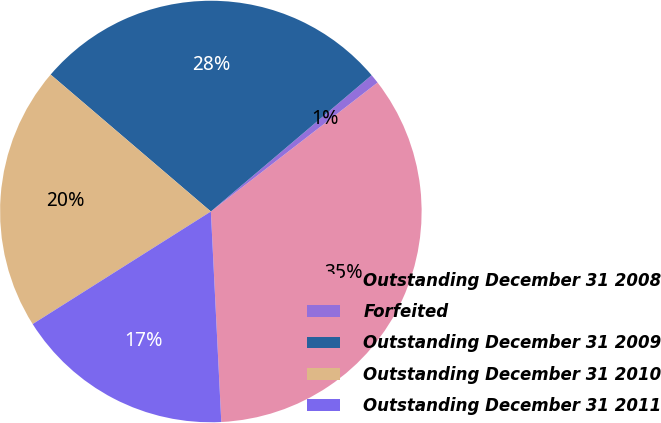Convert chart to OTSL. <chart><loc_0><loc_0><loc_500><loc_500><pie_chart><fcel>Outstanding December 31 2008<fcel>Forfeited<fcel>Outstanding December 31 2009<fcel>Outstanding December 31 2010<fcel>Outstanding December 31 2011<nl><fcel>34.69%<fcel>0.71%<fcel>27.55%<fcel>20.22%<fcel>16.82%<nl></chart> 